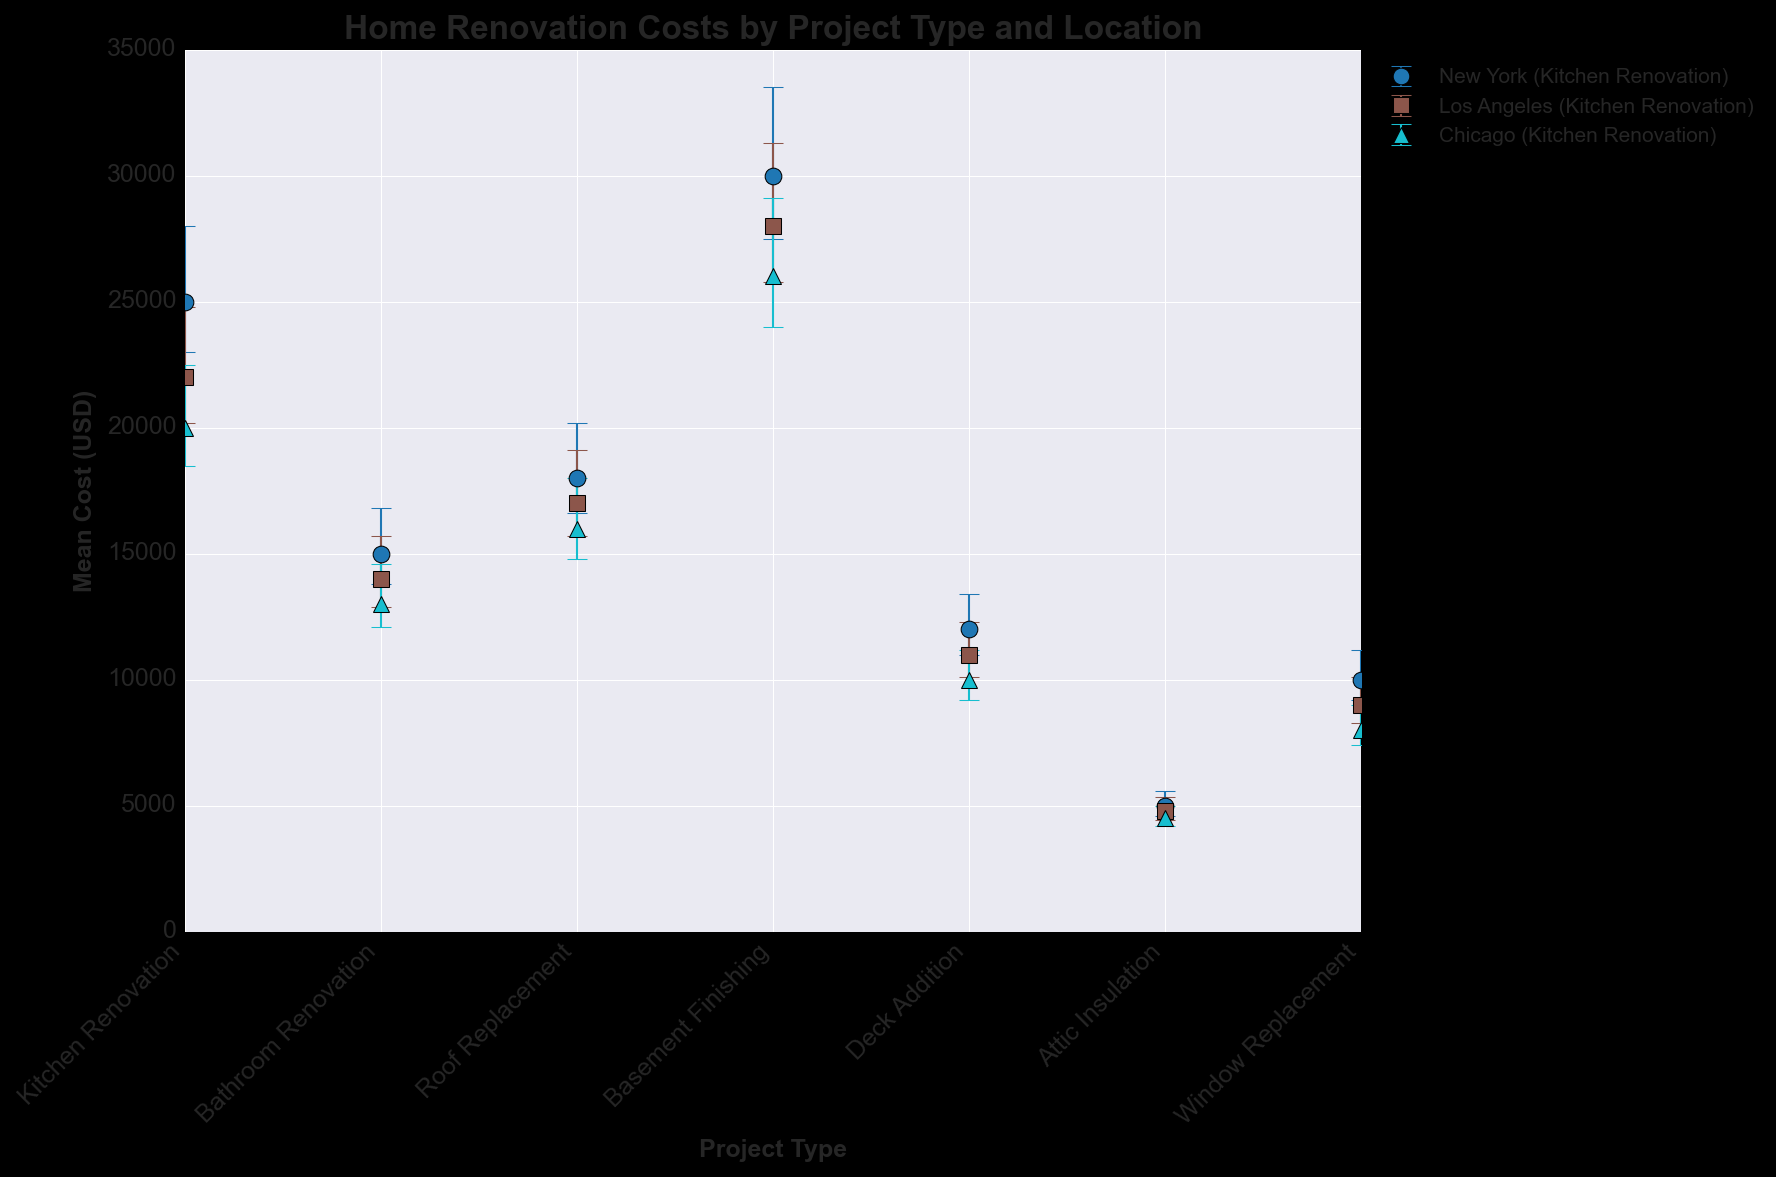Which project type in New York has the highest mean cost? By examining the error bar chart, we notice that the basement finishing project in New York has the highest mean cost because it reaches 30,000 USD, which is higher than the other project types.
Answer: Basement Finishing What is the difference in mean cost between a roof replacement in New York and Los Angeles? The mean cost of roof replacement in New York is 18,000 USD, and in Los Angeles, it is 17,000 USD. Subtracting the two gives 18,000 - 17,000 = 1,000 USD.
Answer: 1,000 USD How does the mean cost of kitchen renovation in Los Angeles compare with that in Chicago? Comparing the error bars for kitchen renovation, we see that the mean cost in Los Angeles is 22,000 USD and in Chicago, it is 20,000 USD. Los Angeles is higher.
Answer: Higher in Los Angeles Which project type and location combination has the lowest recorded error margin? By examining the error bar lengths, the attic insulation project in Chicago has the lowest error margin, with an error range of 300 to 500 USD (total 200 USD).
Answer: Attic Insulation in Chicago How much more expensive is basement finishing in New York compared to attic insulation in the same city? The mean cost for basement finishing in New York is 30,000 USD and for attic insulation, it is 5,000 USD. The difference is 30,000 - 5,000 = 25,000 USD.
Answer: 25,000 USD Which city has the highest mean cost for window replacement? Looking at the error bars for window replacement, New York has the highest mean cost at 10,000 USD, compared to Los Angeles and Chicago.
Answer: New York In Chicago, which project type has the smallest mean cost? Examining the error bars in Chicago, attic insulation has the smallest mean cost at 4,500 USD.
Answer: Attic Insulation What is the average of the mean costs for bathroom renovation across all three cities? The mean costs for bathroom renovation are 15,000 USD in New York, 14,000 USD in Los Angeles, and 13,000 USD in Chicago. The average is (15,000 + 14,000 + 13,000) / 3 = 14,000 USD.
Answer: 14,000 USD In Los Angeles, what is the difference in the error margin between kitchen renovation and roof replacement? The error margin for kitchen renovation is from 1,800 to 2,800 USD (total 1,000 USD), and for roof replacement, it is from 1,300 to 2,100 USD (total 800 USD). The difference in the error margin is 1,000 - 800 = 200 USD.
Answer: 200 USD 